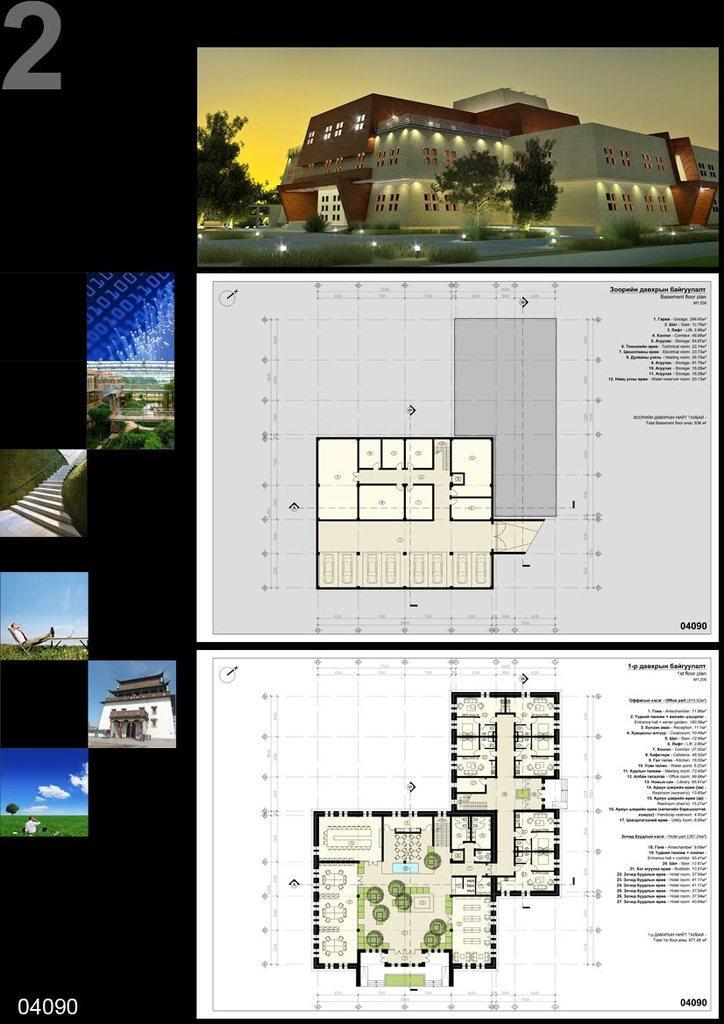Can you describe this image briefly? This picture is a collage of some images. In these images I can observe two layouts of a building. In the other images I can observe buildings and some clouds in the sky. 